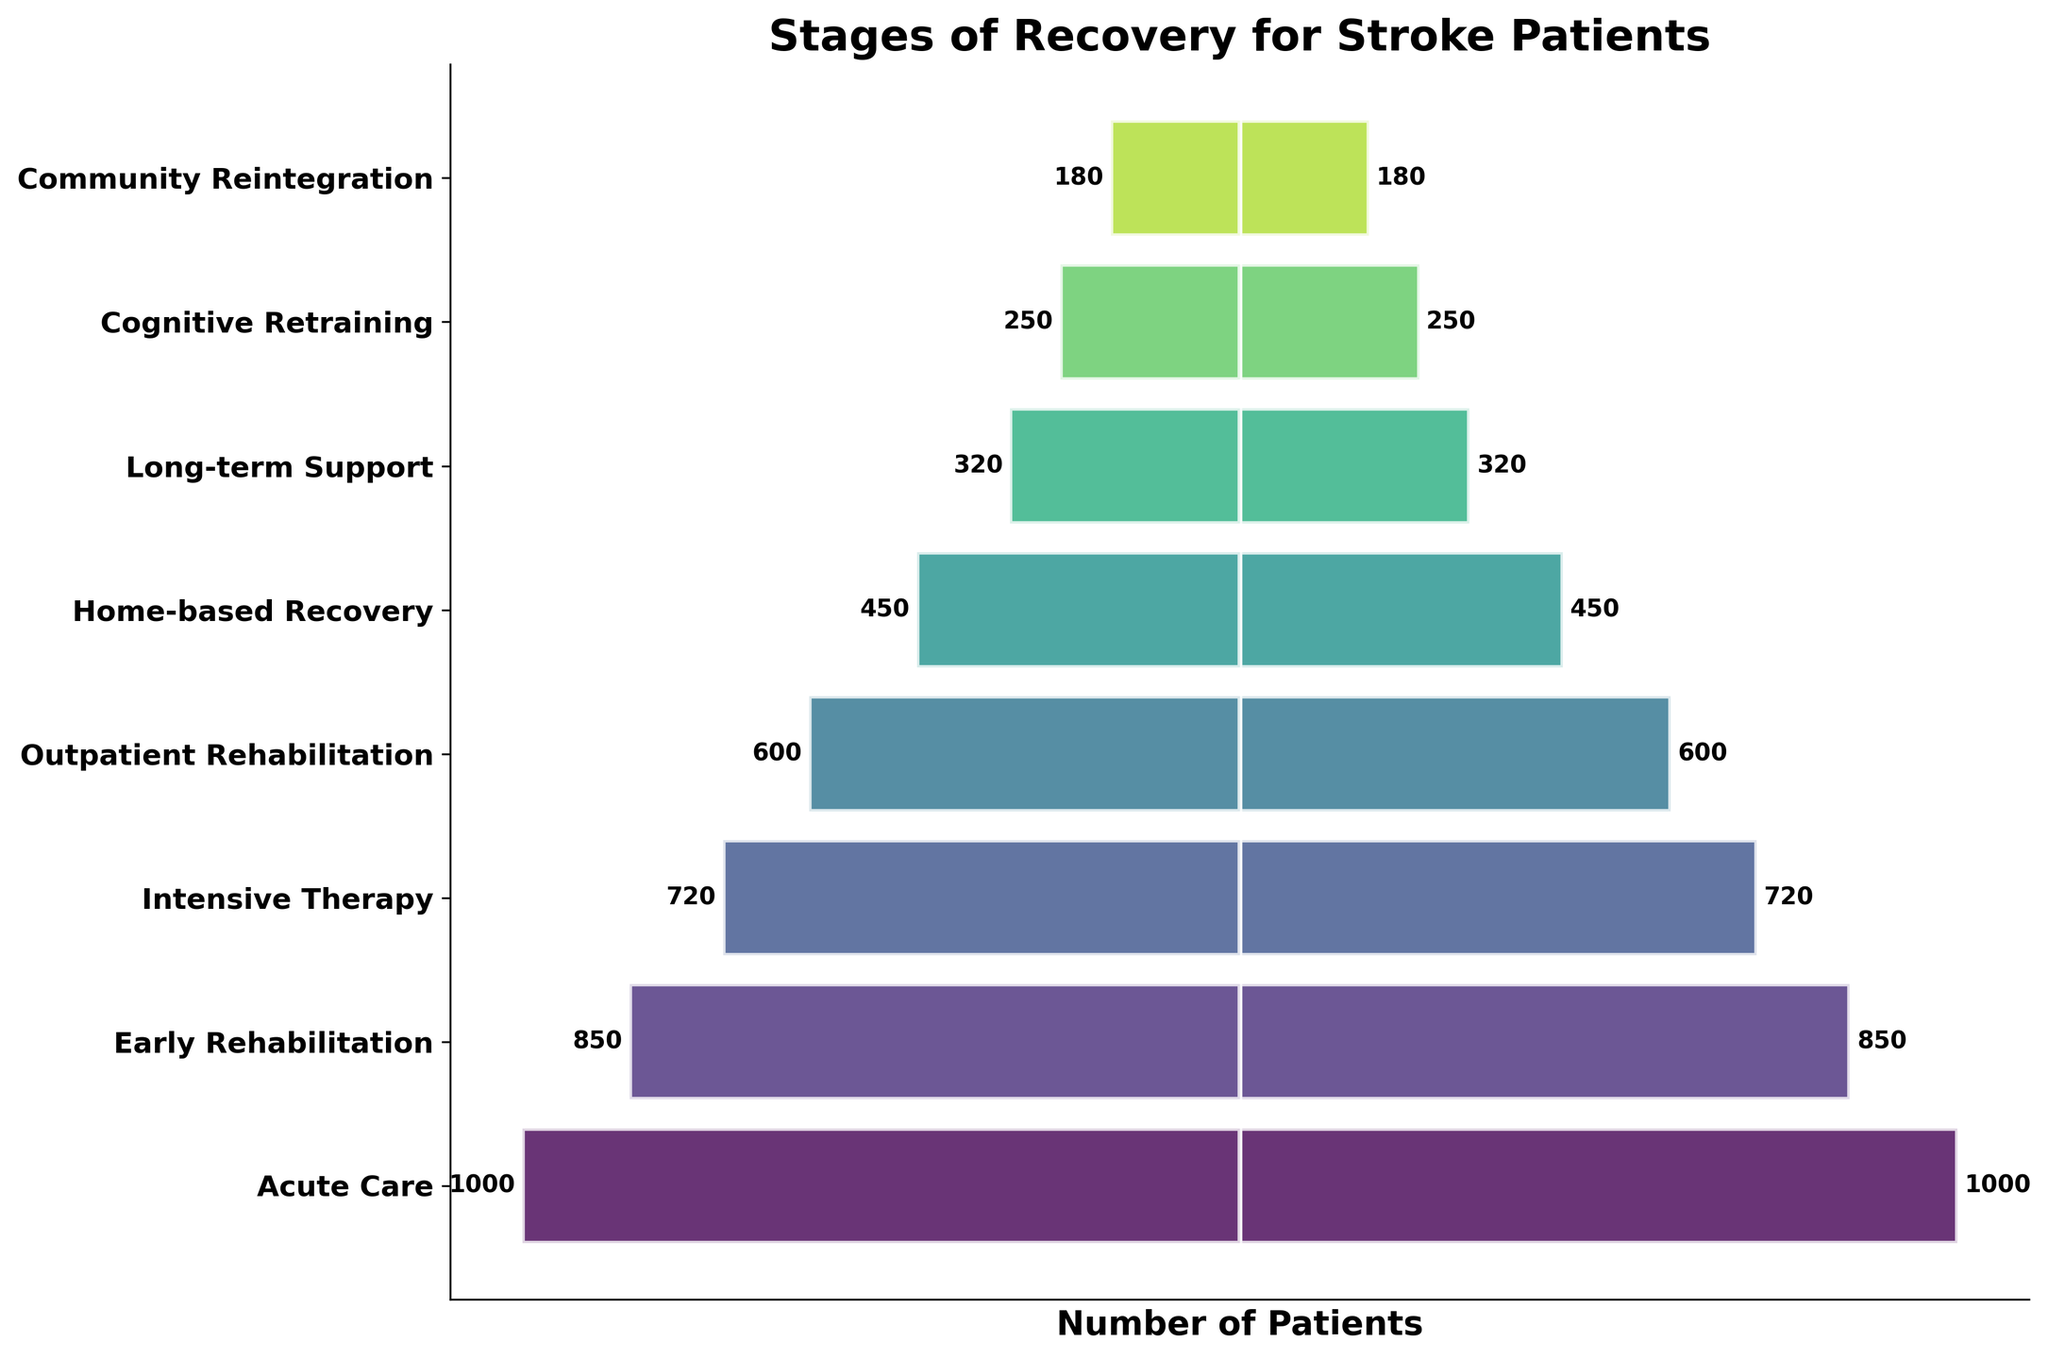What is the title of the figure? The title of the figure is found at the top. It reads "Stages of Recovery for Stroke Patients."
Answer: Stages of Recovery for Stroke Patients How many stages are depicted in the figure? By counting the unique stages labeled along the y-axis, we can see that there are eight stages depicted in the figure.
Answer: 8 Which stage has the highest number of patients? The stage with the highest number of patients is indicated by the longest bar on the plot. It is "Acute Care," with 1000 patients.
Answer: Acute Care What is the number of patients in the Community Reintegration stage? The number of patients for each stage is displayed next to the bars. For Community Reintegration, it is 180 patients.
Answer: 180 How many patients move from Early Rehabilitation to Intensive Therapy? Subtract the number of patients in Intensive Therapy from those in Early Rehabilitation (850 - 720).
Answer: 130 Is the number of patients in Home-based Recovery greater than those in Outpatient Rehabilitation? Compare the lengths of the bars representing these stages. Home-based Recovery has 450 patients, while Outpatient Rehabilitation has 600.
Answer: No What is the total number of patients across all stages? Add the number of patients in each stage: 1000 + 850 + 720 + 600 + 450 + 320 + 250 + 180 = 4370.
Answer: 4370 Which stage has the smallest number of patients, and how many patients are there? The stage with the smallest bar is Community Reintegration, with 180 patients.
Answer: Community Reintegration, 180 How many patients transition from Home-based Recovery to Long-term Support? Subtract the number of patients in Long-term Support from those in Home-based Recovery (450 - 320).
Answer: 130 What is the difference in the number of patients between Intensive Therapy and Cognitive Retraining? Subtract the number of patients in Cognitive Retraining from Intensive Therapy (720 - 250).
Answer: 470 